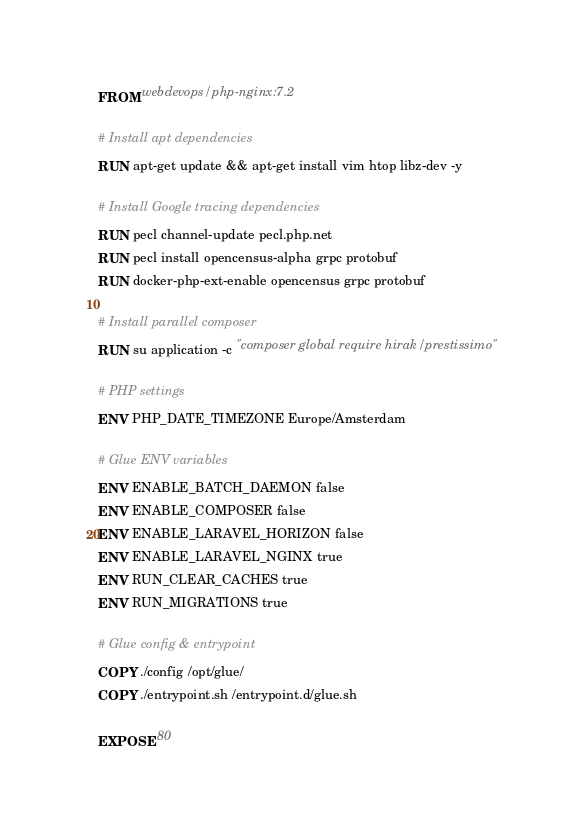Convert code to text. <code><loc_0><loc_0><loc_500><loc_500><_Dockerfile_>FROM webdevops/php-nginx:7.2

# Install apt dependencies
RUN apt-get update && apt-get install vim htop libz-dev -y

# Install Google tracing dependencies
RUN pecl channel-update pecl.php.net
RUN pecl install opencensus-alpha grpc protobuf
RUN docker-php-ext-enable opencensus grpc protobuf

# Install parallel composer
RUN su application -c "composer global require hirak/prestissimo"

# PHP settings
ENV PHP_DATE_TIMEZONE Europe/Amsterdam

# Glue ENV variables
ENV ENABLE_BATCH_DAEMON false
ENV ENABLE_COMPOSER false
ENV ENABLE_LARAVEL_HORIZON false
ENV ENABLE_LARAVEL_NGINX true
ENV RUN_CLEAR_CACHES true
ENV RUN_MIGRATIONS true

# Glue config & entrypoint
COPY ./config /opt/glue/
COPY ./entrypoint.sh /entrypoint.d/glue.sh

EXPOSE 80</code> 